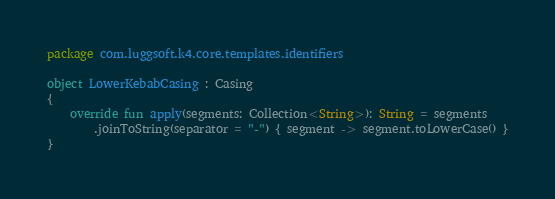<code> <loc_0><loc_0><loc_500><loc_500><_Kotlin_>package com.luggsoft.k4.core.templates.identifiers

object LowerKebabCasing : Casing
{
    override fun apply(segments: Collection<String>): String = segments
        .joinToString(separator = "-") { segment -> segment.toLowerCase() }
}
</code> 